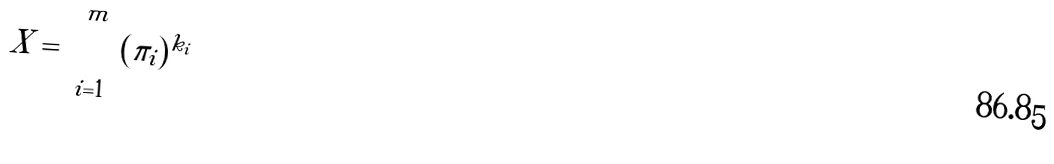Convert formula to latex. <formula><loc_0><loc_0><loc_500><loc_500>X = \prod _ { i = 1 } ^ { m } ( \pi _ { i } ) ^ { k _ { i } }</formula> 